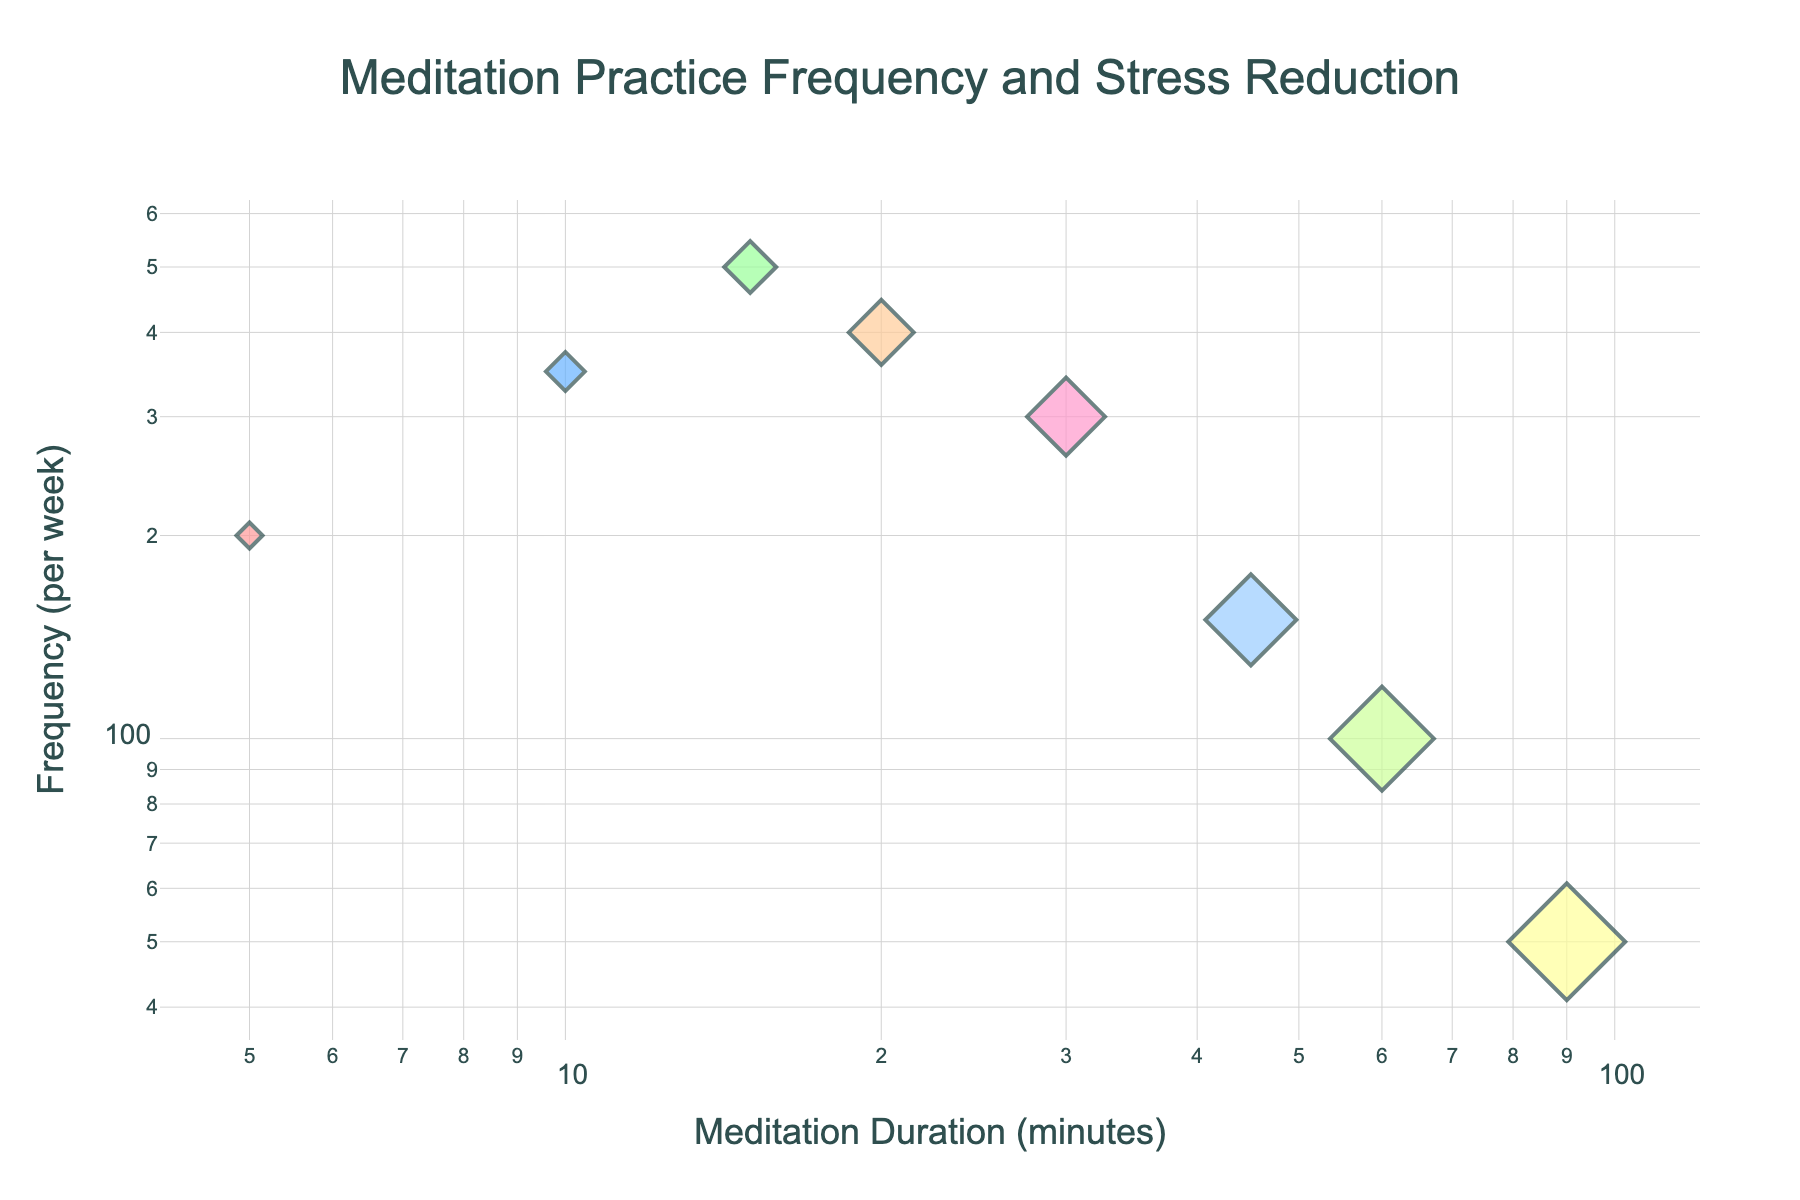What's the title of the figure? The title of the figure is usually displayed at the top-center of the plot. From the given data and code, it is provided as "Meditation Practice Frequency and Stress Reduction".
Answer: Meditation Practice Frequency and Stress Reduction What are the units of measurement used for the x and y axes in the figure? The units can be identified from the axis titles. The x-axis is labeled as "Meditation Duration (minutes)" and the y-axis is labeled as "Frequency (per week)".
Answer: Minutes and per week Which meditation duration has the highest frequency per week? By observing the y-values corresponding to the x-values, the data point with a meditation duration of 15 minutes has the highest y-value of 500.
Answer: 15 minutes How is stress reduction represented in the plot? Stress reduction levels are represented by the size of the markers in the plot. Larger markers indicate higher levels of stress reduction.
Answer: Marker size Which meditation duration is associated with a stress reduction level of 8? By looking at the hover information or the sizes of the markers, the marker corresponding to 60 minutes has a stress reduction level of 8.
Answer: 60 minutes Is there any meditation duration that is associated with both high frequency and high stress reduction? A high frequency combined with high stress reduction would involve larger markers located higher on the y-axis. The 20-minute duration has a frequency of 400 and a stress reduction level of 5.
Answer: Yes, 20 minutes What is the shape of the markers used in the scatter plot? According to the code, the markers are described as diamonds. They are visually distinct and easier to spot.
Answer: Diamonds Which meditation duration shows a frequency of practice that is half of the value of another duration? To solve, find two points where one frequency is half of the other. Comparing values, 15-minute (500) and 30-minute (300, approximately half of 500).
Answer: 30 minutes (half of 15 minutes) What is the smallest frequency reported per week and for which meditation duration? The smallest frequency is found at the lowest point on the y-axis, which is 50, corresponding to a 90-minute duration.
Answer: 50 times, 90 minutes What kind of scale is used for both the x and y axes? By analyzing the plot's axes and looking at their annotation style, both axes are presented with a logarithmic scale as mentioned in the code.
Answer: Logarithmic scale 